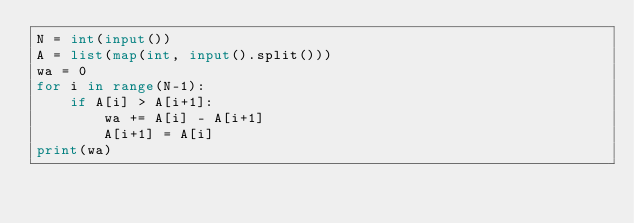<code> <loc_0><loc_0><loc_500><loc_500><_Python_>N = int(input())
A = list(map(int, input().split()))
wa = 0
for i in range(N-1):
    if A[i] > A[i+1]:
        wa += A[i] - A[i+1]
        A[i+1] = A[i]
print(wa)</code> 